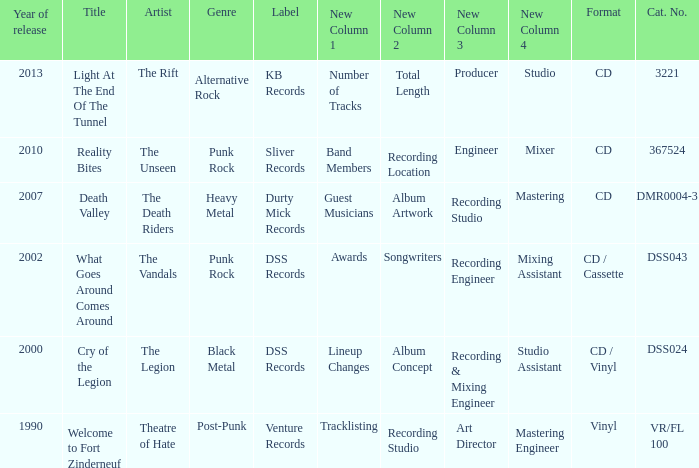What is the total year of release of the title what goes around comes around? 1.0. 